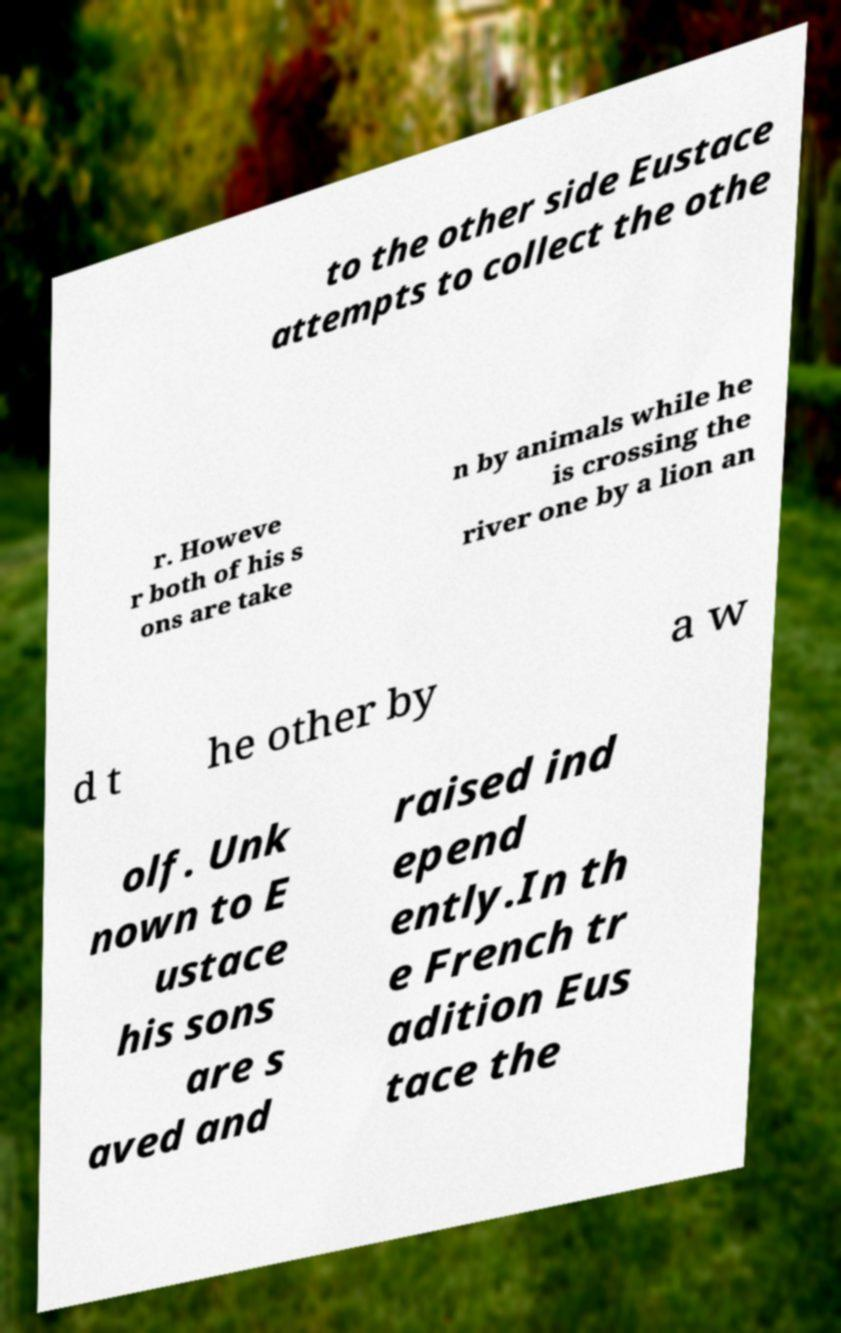Please identify and transcribe the text found in this image. to the other side Eustace attempts to collect the othe r. Howeve r both of his s ons are take n by animals while he is crossing the river one by a lion an d t he other by a w olf. Unk nown to E ustace his sons are s aved and raised ind epend ently.In th e French tr adition Eus tace the 